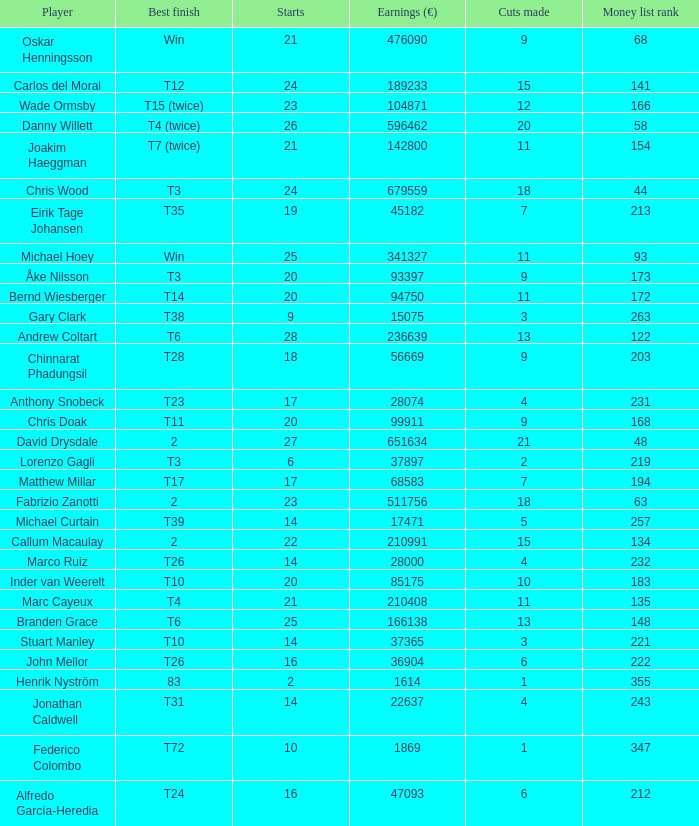How many earnings values are associated with players who had a best finish of T38? 1.0. 